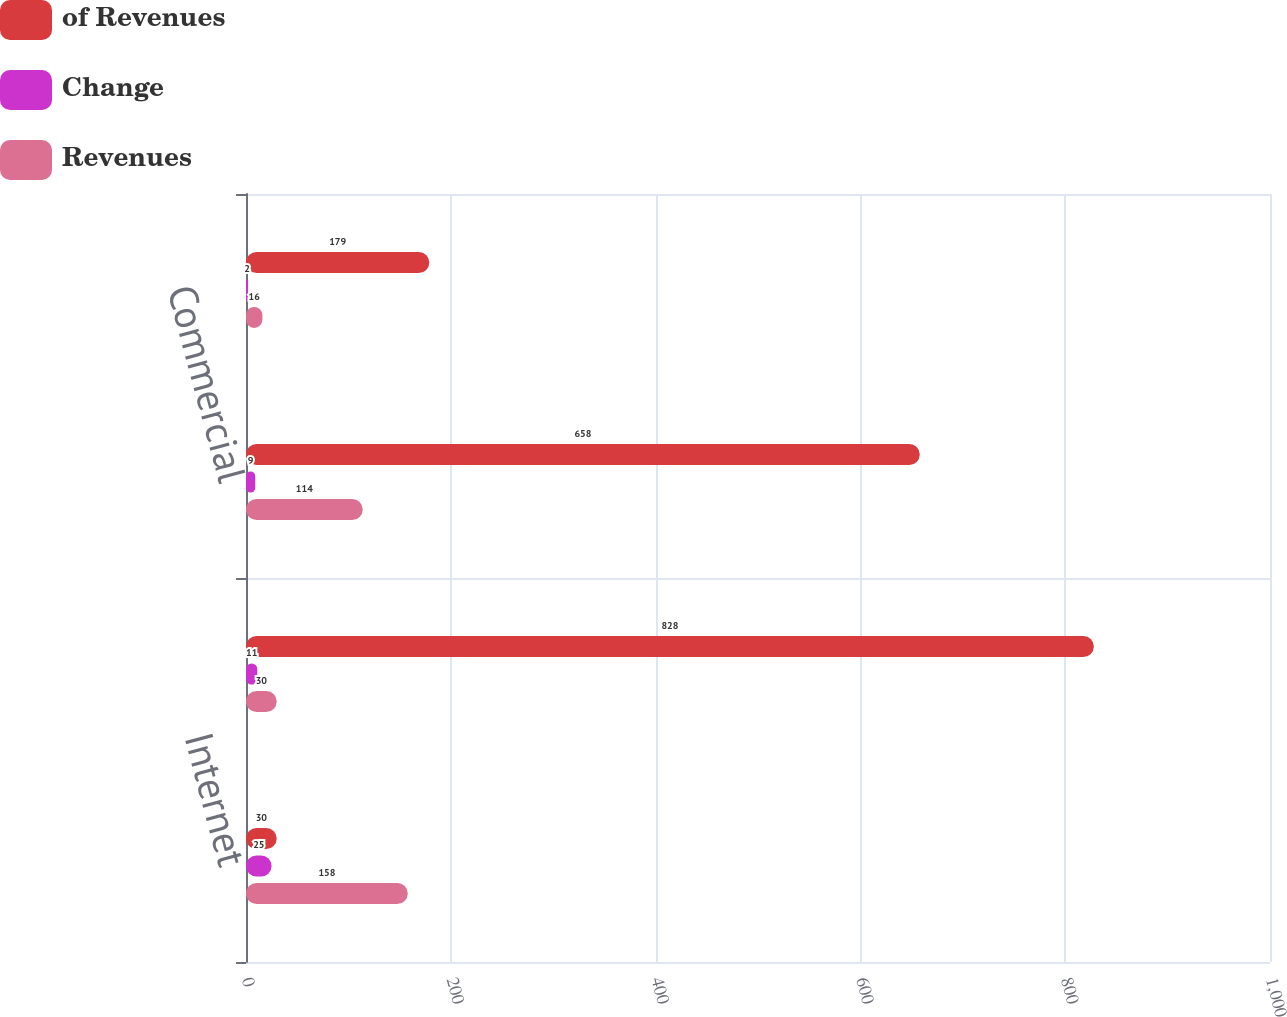Convert chart. <chart><loc_0><loc_0><loc_500><loc_500><stacked_bar_chart><ecel><fcel>Internet<fcel>Telephone<fcel>Commercial<fcel>Other<nl><fcel>of Revenues<fcel>30<fcel>828<fcel>658<fcel>179<nl><fcel>Change<fcel>25<fcel>11<fcel>9<fcel>2<nl><fcel>Revenues<fcel>158<fcel>30<fcel>114<fcel>16<nl></chart> 